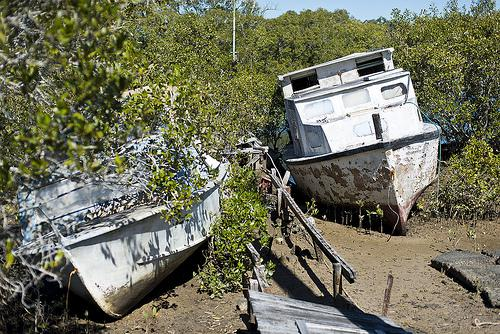Question: who is the focus of the photo?
Choices:
A. The ships.
B. The cars.
C. The bikes.
D. The boats.
Answer with the letter. Answer: D Question: why is the photo illuminated?
Choices:
A. Sunlight.
B. Car light.
C. Red light.
D. Room light.
Answer with the letter. Answer: A Question: where was this photo taken?
Choices:
A. Bus depot.
B. Airport.
C. School.
D. An abandoned beach.
Answer with the letter. Answer: D 